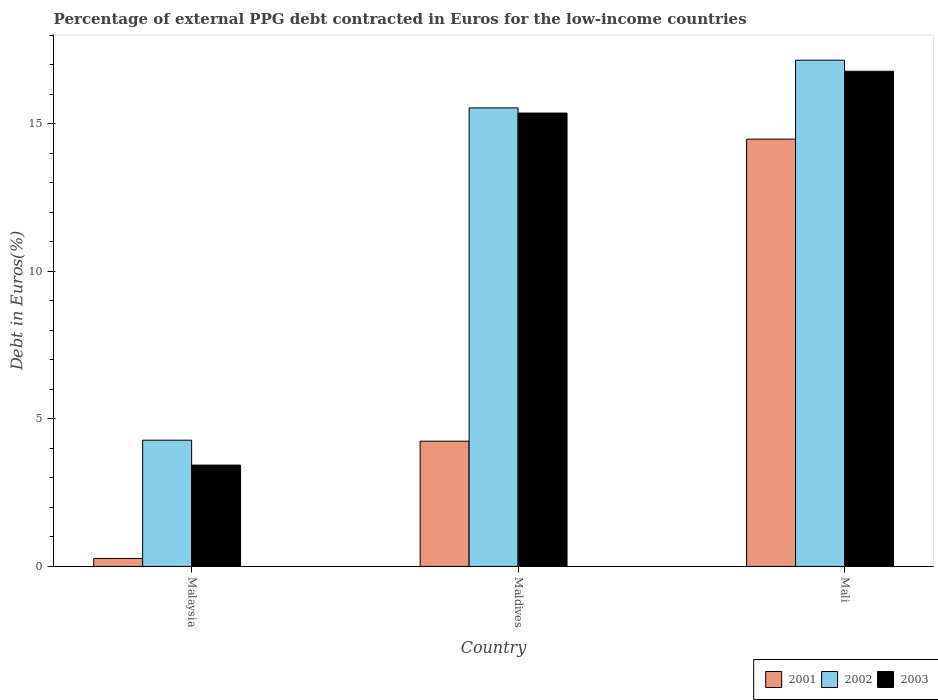How many groups of bars are there?
Offer a very short reply. 3. Are the number of bars per tick equal to the number of legend labels?
Provide a succinct answer. Yes. How many bars are there on the 1st tick from the left?
Provide a succinct answer. 3. How many bars are there on the 1st tick from the right?
Provide a short and direct response. 3. What is the label of the 2nd group of bars from the left?
Provide a succinct answer. Maldives. What is the percentage of external PPG debt contracted in Euros in 2003 in Malaysia?
Give a very brief answer. 3.44. Across all countries, what is the maximum percentage of external PPG debt contracted in Euros in 2003?
Your response must be concise. 16.79. Across all countries, what is the minimum percentage of external PPG debt contracted in Euros in 2001?
Your answer should be compact. 0.27. In which country was the percentage of external PPG debt contracted in Euros in 2003 maximum?
Give a very brief answer. Mali. In which country was the percentage of external PPG debt contracted in Euros in 2003 minimum?
Offer a terse response. Malaysia. What is the total percentage of external PPG debt contracted in Euros in 2003 in the graph?
Your response must be concise. 35.59. What is the difference between the percentage of external PPG debt contracted in Euros in 2003 in Maldives and that in Mali?
Offer a very short reply. -1.42. What is the difference between the percentage of external PPG debt contracted in Euros in 2002 in Malaysia and the percentage of external PPG debt contracted in Euros in 2001 in Mali?
Make the answer very short. -10.21. What is the average percentage of external PPG debt contracted in Euros in 2003 per country?
Provide a succinct answer. 11.86. What is the difference between the percentage of external PPG debt contracted in Euros of/in 2003 and percentage of external PPG debt contracted in Euros of/in 2002 in Maldives?
Offer a terse response. -0.18. In how many countries, is the percentage of external PPG debt contracted in Euros in 2003 greater than 2 %?
Your answer should be very brief. 3. What is the ratio of the percentage of external PPG debt contracted in Euros in 2003 in Malaysia to that in Mali?
Provide a short and direct response. 0.2. Is the difference between the percentage of external PPG debt contracted in Euros in 2003 in Malaysia and Maldives greater than the difference between the percentage of external PPG debt contracted in Euros in 2002 in Malaysia and Maldives?
Provide a short and direct response. No. What is the difference between the highest and the second highest percentage of external PPG debt contracted in Euros in 2002?
Keep it short and to the point. 12.88. What is the difference between the highest and the lowest percentage of external PPG debt contracted in Euros in 2003?
Give a very brief answer. 13.35. In how many countries, is the percentage of external PPG debt contracted in Euros in 2001 greater than the average percentage of external PPG debt contracted in Euros in 2001 taken over all countries?
Provide a short and direct response. 1. What does the 1st bar from the left in Maldives represents?
Give a very brief answer. 2001. What does the 3rd bar from the right in Mali represents?
Give a very brief answer. 2001. What is the difference between two consecutive major ticks on the Y-axis?
Give a very brief answer. 5. Does the graph contain grids?
Ensure brevity in your answer.  No. Where does the legend appear in the graph?
Provide a succinct answer. Bottom right. How many legend labels are there?
Your answer should be very brief. 3. How are the legend labels stacked?
Give a very brief answer. Horizontal. What is the title of the graph?
Keep it short and to the point. Percentage of external PPG debt contracted in Euros for the low-income countries. Does "2005" appear as one of the legend labels in the graph?
Ensure brevity in your answer.  No. What is the label or title of the Y-axis?
Your answer should be compact. Debt in Euros(%). What is the Debt in Euros(%) of 2001 in Malaysia?
Give a very brief answer. 0.27. What is the Debt in Euros(%) in 2002 in Malaysia?
Make the answer very short. 4.28. What is the Debt in Euros(%) in 2003 in Malaysia?
Make the answer very short. 3.44. What is the Debt in Euros(%) in 2001 in Maldives?
Ensure brevity in your answer.  4.25. What is the Debt in Euros(%) of 2002 in Maldives?
Your answer should be compact. 15.55. What is the Debt in Euros(%) in 2003 in Maldives?
Offer a terse response. 15.37. What is the Debt in Euros(%) of 2001 in Mali?
Give a very brief answer. 14.49. What is the Debt in Euros(%) of 2002 in Mali?
Give a very brief answer. 17.16. What is the Debt in Euros(%) in 2003 in Mali?
Make the answer very short. 16.79. Across all countries, what is the maximum Debt in Euros(%) in 2001?
Your answer should be very brief. 14.49. Across all countries, what is the maximum Debt in Euros(%) of 2002?
Provide a short and direct response. 17.16. Across all countries, what is the maximum Debt in Euros(%) of 2003?
Your answer should be very brief. 16.79. Across all countries, what is the minimum Debt in Euros(%) in 2001?
Your answer should be very brief. 0.27. Across all countries, what is the minimum Debt in Euros(%) in 2002?
Your answer should be compact. 4.28. Across all countries, what is the minimum Debt in Euros(%) in 2003?
Your answer should be compact. 3.44. What is the total Debt in Euros(%) of 2001 in the graph?
Your answer should be very brief. 19. What is the total Debt in Euros(%) in 2002 in the graph?
Your answer should be compact. 36.99. What is the total Debt in Euros(%) of 2003 in the graph?
Ensure brevity in your answer.  35.59. What is the difference between the Debt in Euros(%) in 2001 in Malaysia and that in Maldives?
Provide a succinct answer. -3.98. What is the difference between the Debt in Euros(%) in 2002 in Malaysia and that in Maldives?
Give a very brief answer. -11.27. What is the difference between the Debt in Euros(%) of 2003 in Malaysia and that in Maldives?
Provide a succinct answer. -11.93. What is the difference between the Debt in Euros(%) in 2001 in Malaysia and that in Mali?
Your answer should be compact. -14.22. What is the difference between the Debt in Euros(%) in 2002 in Malaysia and that in Mali?
Your answer should be compact. -12.88. What is the difference between the Debt in Euros(%) of 2003 in Malaysia and that in Mali?
Offer a terse response. -13.35. What is the difference between the Debt in Euros(%) in 2001 in Maldives and that in Mali?
Ensure brevity in your answer.  -10.24. What is the difference between the Debt in Euros(%) in 2002 in Maldives and that in Mali?
Keep it short and to the point. -1.62. What is the difference between the Debt in Euros(%) in 2003 in Maldives and that in Mali?
Provide a short and direct response. -1.42. What is the difference between the Debt in Euros(%) of 2001 in Malaysia and the Debt in Euros(%) of 2002 in Maldives?
Provide a succinct answer. -15.28. What is the difference between the Debt in Euros(%) of 2001 in Malaysia and the Debt in Euros(%) of 2003 in Maldives?
Make the answer very short. -15.1. What is the difference between the Debt in Euros(%) in 2002 in Malaysia and the Debt in Euros(%) in 2003 in Maldives?
Your answer should be compact. -11.09. What is the difference between the Debt in Euros(%) in 2001 in Malaysia and the Debt in Euros(%) in 2002 in Mali?
Your answer should be compact. -16.89. What is the difference between the Debt in Euros(%) of 2001 in Malaysia and the Debt in Euros(%) of 2003 in Mali?
Keep it short and to the point. -16.52. What is the difference between the Debt in Euros(%) in 2002 in Malaysia and the Debt in Euros(%) in 2003 in Mali?
Offer a terse response. -12.51. What is the difference between the Debt in Euros(%) of 2001 in Maldives and the Debt in Euros(%) of 2002 in Mali?
Your answer should be very brief. -12.92. What is the difference between the Debt in Euros(%) in 2001 in Maldives and the Debt in Euros(%) in 2003 in Mali?
Provide a succinct answer. -12.54. What is the difference between the Debt in Euros(%) in 2002 in Maldives and the Debt in Euros(%) in 2003 in Mali?
Offer a terse response. -1.24. What is the average Debt in Euros(%) of 2001 per country?
Provide a short and direct response. 6.33. What is the average Debt in Euros(%) of 2002 per country?
Keep it short and to the point. 12.33. What is the average Debt in Euros(%) of 2003 per country?
Provide a short and direct response. 11.86. What is the difference between the Debt in Euros(%) in 2001 and Debt in Euros(%) in 2002 in Malaysia?
Keep it short and to the point. -4.01. What is the difference between the Debt in Euros(%) of 2001 and Debt in Euros(%) of 2003 in Malaysia?
Provide a succinct answer. -3.16. What is the difference between the Debt in Euros(%) of 2002 and Debt in Euros(%) of 2003 in Malaysia?
Your answer should be very brief. 0.84. What is the difference between the Debt in Euros(%) of 2001 and Debt in Euros(%) of 2002 in Maldives?
Keep it short and to the point. -11.3. What is the difference between the Debt in Euros(%) of 2001 and Debt in Euros(%) of 2003 in Maldives?
Your answer should be very brief. -11.12. What is the difference between the Debt in Euros(%) in 2002 and Debt in Euros(%) in 2003 in Maldives?
Your answer should be compact. 0.18. What is the difference between the Debt in Euros(%) of 2001 and Debt in Euros(%) of 2002 in Mali?
Your answer should be compact. -2.68. What is the difference between the Debt in Euros(%) in 2001 and Debt in Euros(%) in 2003 in Mali?
Offer a terse response. -2.3. What is the difference between the Debt in Euros(%) of 2002 and Debt in Euros(%) of 2003 in Mali?
Ensure brevity in your answer.  0.38. What is the ratio of the Debt in Euros(%) of 2001 in Malaysia to that in Maldives?
Provide a succinct answer. 0.06. What is the ratio of the Debt in Euros(%) in 2002 in Malaysia to that in Maldives?
Make the answer very short. 0.28. What is the ratio of the Debt in Euros(%) in 2003 in Malaysia to that in Maldives?
Your response must be concise. 0.22. What is the ratio of the Debt in Euros(%) in 2001 in Malaysia to that in Mali?
Offer a terse response. 0.02. What is the ratio of the Debt in Euros(%) in 2002 in Malaysia to that in Mali?
Provide a succinct answer. 0.25. What is the ratio of the Debt in Euros(%) of 2003 in Malaysia to that in Mali?
Your answer should be compact. 0.2. What is the ratio of the Debt in Euros(%) of 2001 in Maldives to that in Mali?
Provide a short and direct response. 0.29. What is the ratio of the Debt in Euros(%) in 2002 in Maldives to that in Mali?
Provide a succinct answer. 0.91. What is the ratio of the Debt in Euros(%) in 2003 in Maldives to that in Mali?
Ensure brevity in your answer.  0.92. What is the difference between the highest and the second highest Debt in Euros(%) of 2001?
Offer a very short reply. 10.24. What is the difference between the highest and the second highest Debt in Euros(%) in 2002?
Your answer should be compact. 1.62. What is the difference between the highest and the second highest Debt in Euros(%) of 2003?
Your response must be concise. 1.42. What is the difference between the highest and the lowest Debt in Euros(%) of 2001?
Your answer should be very brief. 14.22. What is the difference between the highest and the lowest Debt in Euros(%) of 2002?
Your response must be concise. 12.88. What is the difference between the highest and the lowest Debt in Euros(%) of 2003?
Your answer should be very brief. 13.35. 